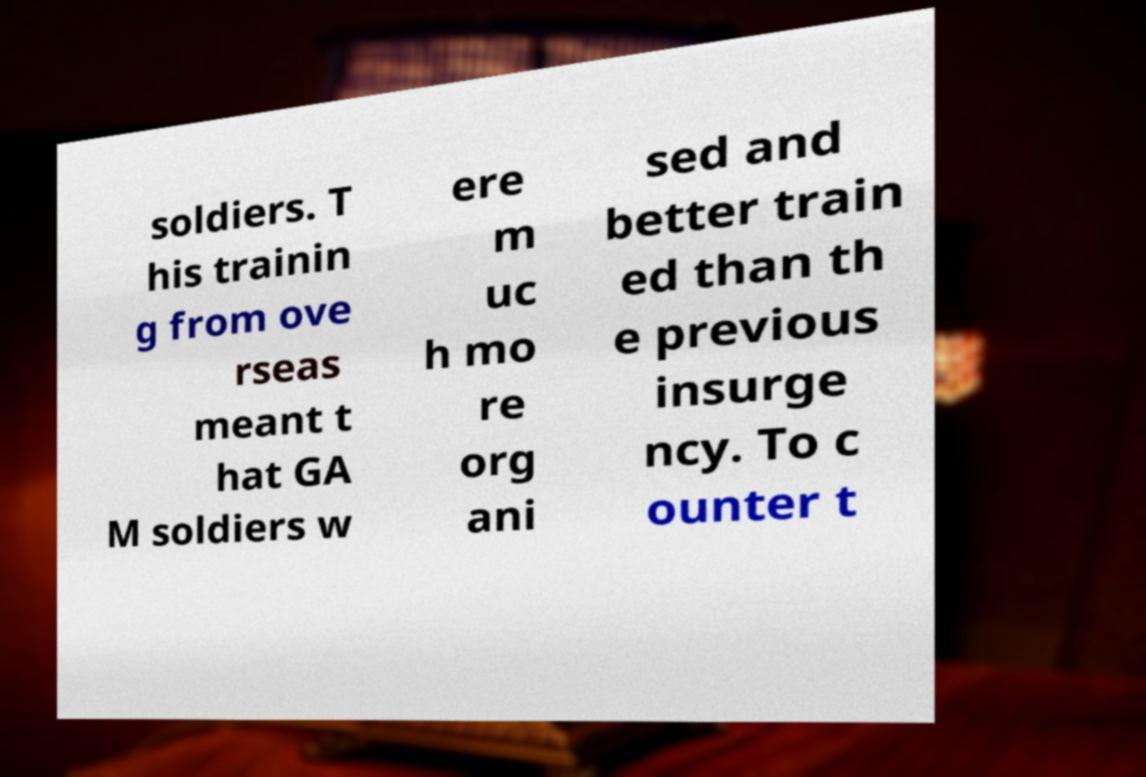Can you read and provide the text displayed in the image?This photo seems to have some interesting text. Can you extract and type it out for me? soldiers. T his trainin g from ove rseas meant t hat GA M soldiers w ere m uc h mo re org ani sed and better train ed than th e previous insurge ncy. To c ounter t 